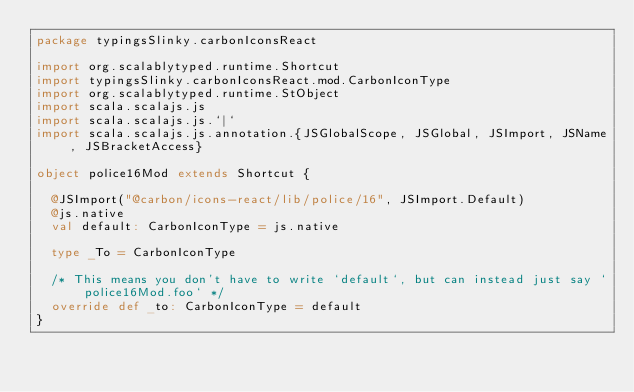<code> <loc_0><loc_0><loc_500><loc_500><_Scala_>package typingsSlinky.carbonIconsReact

import org.scalablytyped.runtime.Shortcut
import typingsSlinky.carbonIconsReact.mod.CarbonIconType
import org.scalablytyped.runtime.StObject
import scala.scalajs.js
import scala.scalajs.js.`|`
import scala.scalajs.js.annotation.{JSGlobalScope, JSGlobal, JSImport, JSName, JSBracketAccess}

object police16Mod extends Shortcut {
  
  @JSImport("@carbon/icons-react/lib/police/16", JSImport.Default)
  @js.native
  val default: CarbonIconType = js.native
  
  type _To = CarbonIconType
  
  /* This means you don't have to write `default`, but can instead just say `police16Mod.foo` */
  override def _to: CarbonIconType = default
}
</code> 